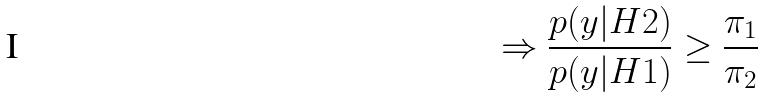<formula> <loc_0><loc_0><loc_500><loc_500>\Rightarrow \frac { p ( y | H 2 ) } { p ( y | H 1 ) } \geq \frac { \pi _ { 1 } } { \pi _ { 2 } }</formula> 